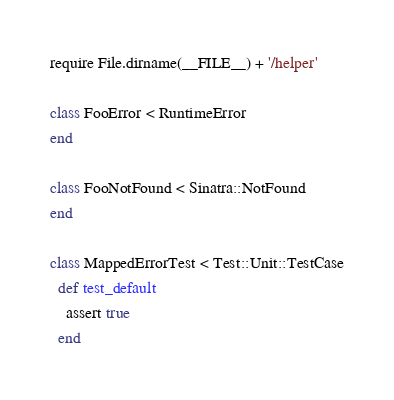<code> <loc_0><loc_0><loc_500><loc_500><_Ruby_>require File.dirname(__FILE__) + '/helper'

class FooError < RuntimeError
end

class FooNotFound < Sinatra::NotFound
end

class MappedErrorTest < Test::Unit::TestCase
  def test_default
    assert true
  end
</code> 